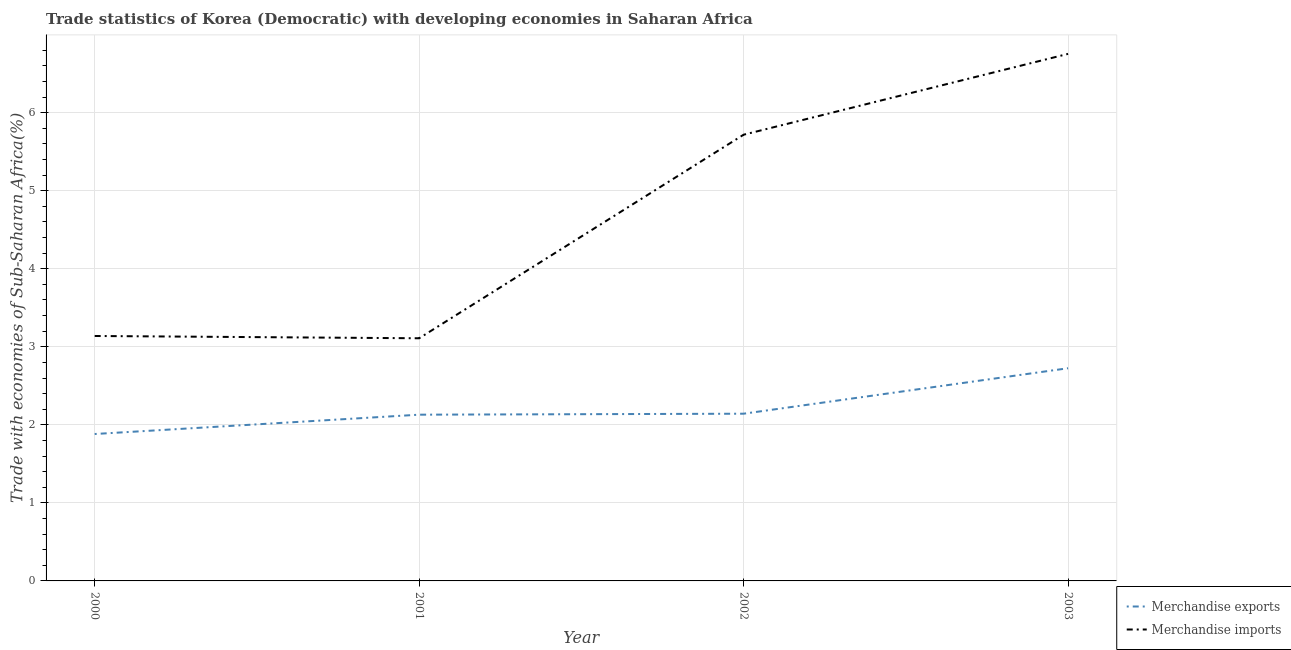How many different coloured lines are there?
Make the answer very short. 2. Does the line corresponding to merchandise imports intersect with the line corresponding to merchandise exports?
Give a very brief answer. No. What is the merchandise imports in 2000?
Make the answer very short. 3.14. Across all years, what is the maximum merchandise imports?
Offer a very short reply. 6.75. Across all years, what is the minimum merchandise imports?
Provide a short and direct response. 3.11. In which year was the merchandise imports maximum?
Offer a terse response. 2003. What is the total merchandise imports in the graph?
Provide a succinct answer. 18.72. What is the difference between the merchandise imports in 2001 and that in 2003?
Offer a very short reply. -3.64. What is the difference between the merchandise imports in 2003 and the merchandise exports in 2002?
Your answer should be compact. 4.61. What is the average merchandise imports per year?
Provide a succinct answer. 4.68. In the year 2001, what is the difference between the merchandise imports and merchandise exports?
Give a very brief answer. 0.98. In how many years, is the merchandise exports greater than 5.8 %?
Make the answer very short. 0. What is the ratio of the merchandise exports in 2001 to that in 2002?
Keep it short and to the point. 0.99. Is the difference between the merchandise exports in 2000 and 2002 greater than the difference between the merchandise imports in 2000 and 2002?
Offer a terse response. Yes. What is the difference between the highest and the second highest merchandise exports?
Offer a terse response. 0.58. What is the difference between the highest and the lowest merchandise imports?
Give a very brief answer. 3.64. Is the sum of the merchandise exports in 2000 and 2003 greater than the maximum merchandise imports across all years?
Make the answer very short. No. Is the merchandise imports strictly less than the merchandise exports over the years?
Provide a short and direct response. No. How many years are there in the graph?
Make the answer very short. 4. What is the difference between two consecutive major ticks on the Y-axis?
Make the answer very short. 1. Does the graph contain grids?
Provide a succinct answer. Yes. What is the title of the graph?
Give a very brief answer. Trade statistics of Korea (Democratic) with developing economies in Saharan Africa. What is the label or title of the Y-axis?
Your response must be concise. Trade with economies of Sub-Saharan Africa(%). What is the Trade with economies of Sub-Saharan Africa(%) of Merchandise exports in 2000?
Your answer should be compact. 1.88. What is the Trade with economies of Sub-Saharan Africa(%) in Merchandise imports in 2000?
Make the answer very short. 3.14. What is the Trade with economies of Sub-Saharan Africa(%) in Merchandise exports in 2001?
Give a very brief answer. 2.13. What is the Trade with economies of Sub-Saharan Africa(%) of Merchandise imports in 2001?
Provide a succinct answer. 3.11. What is the Trade with economies of Sub-Saharan Africa(%) in Merchandise exports in 2002?
Offer a terse response. 2.14. What is the Trade with economies of Sub-Saharan Africa(%) of Merchandise imports in 2002?
Your response must be concise. 5.72. What is the Trade with economies of Sub-Saharan Africa(%) of Merchandise exports in 2003?
Offer a very short reply. 2.73. What is the Trade with economies of Sub-Saharan Africa(%) of Merchandise imports in 2003?
Provide a short and direct response. 6.75. Across all years, what is the maximum Trade with economies of Sub-Saharan Africa(%) in Merchandise exports?
Provide a short and direct response. 2.73. Across all years, what is the maximum Trade with economies of Sub-Saharan Africa(%) in Merchandise imports?
Make the answer very short. 6.75. Across all years, what is the minimum Trade with economies of Sub-Saharan Africa(%) of Merchandise exports?
Offer a very short reply. 1.88. Across all years, what is the minimum Trade with economies of Sub-Saharan Africa(%) of Merchandise imports?
Make the answer very short. 3.11. What is the total Trade with economies of Sub-Saharan Africa(%) in Merchandise exports in the graph?
Provide a succinct answer. 8.88. What is the total Trade with economies of Sub-Saharan Africa(%) of Merchandise imports in the graph?
Offer a very short reply. 18.72. What is the difference between the Trade with economies of Sub-Saharan Africa(%) in Merchandise exports in 2000 and that in 2001?
Your response must be concise. -0.25. What is the difference between the Trade with economies of Sub-Saharan Africa(%) in Merchandise imports in 2000 and that in 2001?
Provide a succinct answer. 0.03. What is the difference between the Trade with economies of Sub-Saharan Africa(%) of Merchandise exports in 2000 and that in 2002?
Provide a short and direct response. -0.26. What is the difference between the Trade with economies of Sub-Saharan Africa(%) of Merchandise imports in 2000 and that in 2002?
Ensure brevity in your answer.  -2.58. What is the difference between the Trade with economies of Sub-Saharan Africa(%) in Merchandise exports in 2000 and that in 2003?
Provide a short and direct response. -0.84. What is the difference between the Trade with economies of Sub-Saharan Africa(%) of Merchandise imports in 2000 and that in 2003?
Make the answer very short. -3.61. What is the difference between the Trade with economies of Sub-Saharan Africa(%) of Merchandise exports in 2001 and that in 2002?
Offer a very short reply. -0.01. What is the difference between the Trade with economies of Sub-Saharan Africa(%) in Merchandise imports in 2001 and that in 2002?
Your answer should be compact. -2.61. What is the difference between the Trade with economies of Sub-Saharan Africa(%) of Merchandise exports in 2001 and that in 2003?
Your answer should be very brief. -0.6. What is the difference between the Trade with economies of Sub-Saharan Africa(%) of Merchandise imports in 2001 and that in 2003?
Make the answer very short. -3.64. What is the difference between the Trade with economies of Sub-Saharan Africa(%) of Merchandise exports in 2002 and that in 2003?
Your answer should be compact. -0.58. What is the difference between the Trade with economies of Sub-Saharan Africa(%) of Merchandise imports in 2002 and that in 2003?
Your response must be concise. -1.04. What is the difference between the Trade with economies of Sub-Saharan Africa(%) of Merchandise exports in 2000 and the Trade with economies of Sub-Saharan Africa(%) of Merchandise imports in 2001?
Give a very brief answer. -1.23. What is the difference between the Trade with economies of Sub-Saharan Africa(%) of Merchandise exports in 2000 and the Trade with economies of Sub-Saharan Africa(%) of Merchandise imports in 2002?
Keep it short and to the point. -3.84. What is the difference between the Trade with economies of Sub-Saharan Africa(%) in Merchandise exports in 2000 and the Trade with economies of Sub-Saharan Africa(%) in Merchandise imports in 2003?
Provide a succinct answer. -4.87. What is the difference between the Trade with economies of Sub-Saharan Africa(%) of Merchandise exports in 2001 and the Trade with economies of Sub-Saharan Africa(%) of Merchandise imports in 2002?
Provide a succinct answer. -3.59. What is the difference between the Trade with economies of Sub-Saharan Africa(%) in Merchandise exports in 2001 and the Trade with economies of Sub-Saharan Africa(%) in Merchandise imports in 2003?
Your response must be concise. -4.62. What is the difference between the Trade with economies of Sub-Saharan Africa(%) in Merchandise exports in 2002 and the Trade with economies of Sub-Saharan Africa(%) in Merchandise imports in 2003?
Your answer should be very brief. -4.61. What is the average Trade with economies of Sub-Saharan Africa(%) of Merchandise exports per year?
Your response must be concise. 2.22. What is the average Trade with economies of Sub-Saharan Africa(%) of Merchandise imports per year?
Provide a succinct answer. 4.68. In the year 2000, what is the difference between the Trade with economies of Sub-Saharan Africa(%) in Merchandise exports and Trade with economies of Sub-Saharan Africa(%) in Merchandise imports?
Ensure brevity in your answer.  -1.26. In the year 2001, what is the difference between the Trade with economies of Sub-Saharan Africa(%) of Merchandise exports and Trade with economies of Sub-Saharan Africa(%) of Merchandise imports?
Your answer should be very brief. -0.98. In the year 2002, what is the difference between the Trade with economies of Sub-Saharan Africa(%) in Merchandise exports and Trade with economies of Sub-Saharan Africa(%) in Merchandise imports?
Make the answer very short. -3.57. In the year 2003, what is the difference between the Trade with economies of Sub-Saharan Africa(%) in Merchandise exports and Trade with economies of Sub-Saharan Africa(%) in Merchandise imports?
Make the answer very short. -4.03. What is the ratio of the Trade with economies of Sub-Saharan Africa(%) in Merchandise exports in 2000 to that in 2001?
Your answer should be very brief. 0.88. What is the ratio of the Trade with economies of Sub-Saharan Africa(%) in Merchandise imports in 2000 to that in 2001?
Ensure brevity in your answer.  1.01. What is the ratio of the Trade with economies of Sub-Saharan Africa(%) in Merchandise exports in 2000 to that in 2002?
Provide a succinct answer. 0.88. What is the ratio of the Trade with economies of Sub-Saharan Africa(%) of Merchandise imports in 2000 to that in 2002?
Your answer should be very brief. 0.55. What is the ratio of the Trade with economies of Sub-Saharan Africa(%) of Merchandise exports in 2000 to that in 2003?
Provide a succinct answer. 0.69. What is the ratio of the Trade with economies of Sub-Saharan Africa(%) of Merchandise imports in 2000 to that in 2003?
Offer a very short reply. 0.46. What is the ratio of the Trade with economies of Sub-Saharan Africa(%) in Merchandise imports in 2001 to that in 2002?
Your answer should be compact. 0.54. What is the ratio of the Trade with economies of Sub-Saharan Africa(%) in Merchandise exports in 2001 to that in 2003?
Provide a short and direct response. 0.78. What is the ratio of the Trade with economies of Sub-Saharan Africa(%) in Merchandise imports in 2001 to that in 2003?
Keep it short and to the point. 0.46. What is the ratio of the Trade with economies of Sub-Saharan Africa(%) of Merchandise exports in 2002 to that in 2003?
Offer a terse response. 0.79. What is the ratio of the Trade with economies of Sub-Saharan Africa(%) of Merchandise imports in 2002 to that in 2003?
Provide a short and direct response. 0.85. What is the difference between the highest and the second highest Trade with economies of Sub-Saharan Africa(%) in Merchandise exports?
Keep it short and to the point. 0.58. What is the difference between the highest and the second highest Trade with economies of Sub-Saharan Africa(%) in Merchandise imports?
Provide a short and direct response. 1.04. What is the difference between the highest and the lowest Trade with economies of Sub-Saharan Africa(%) in Merchandise exports?
Ensure brevity in your answer.  0.84. What is the difference between the highest and the lowest Trade with economies of Sub-Saharan Africa(%) of Merchandise imports?
Make the answer very short. 3.64. 